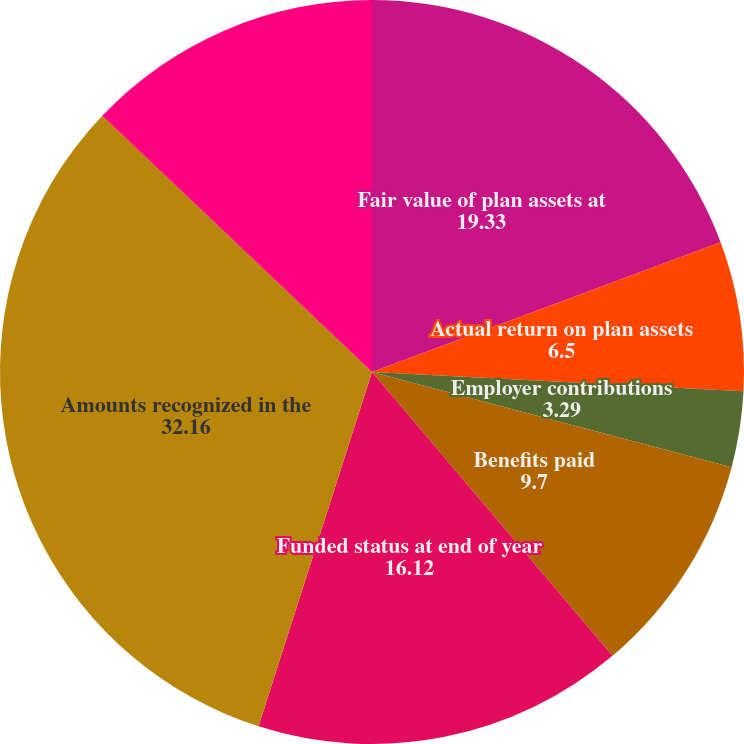Convert chart to OTSL. <chart><loc_0><loc_0><loc_500><loc_500><pie_chart><fcel>Fair value of plan assets at<fcel>Actual return on plan assets<fcel>Employer contributions<fcel>Benefits paid<fcel>Funded status at end of year<fcel>Amounts recognized in the<fcel>Accrued benefit<nl><fcel>19.33%<fcel>6.5%<fcel>3.29%<fcel>9.7%<fcel>16.12%<fcel>32.16%<fcel>12.91%<nl></chart> 